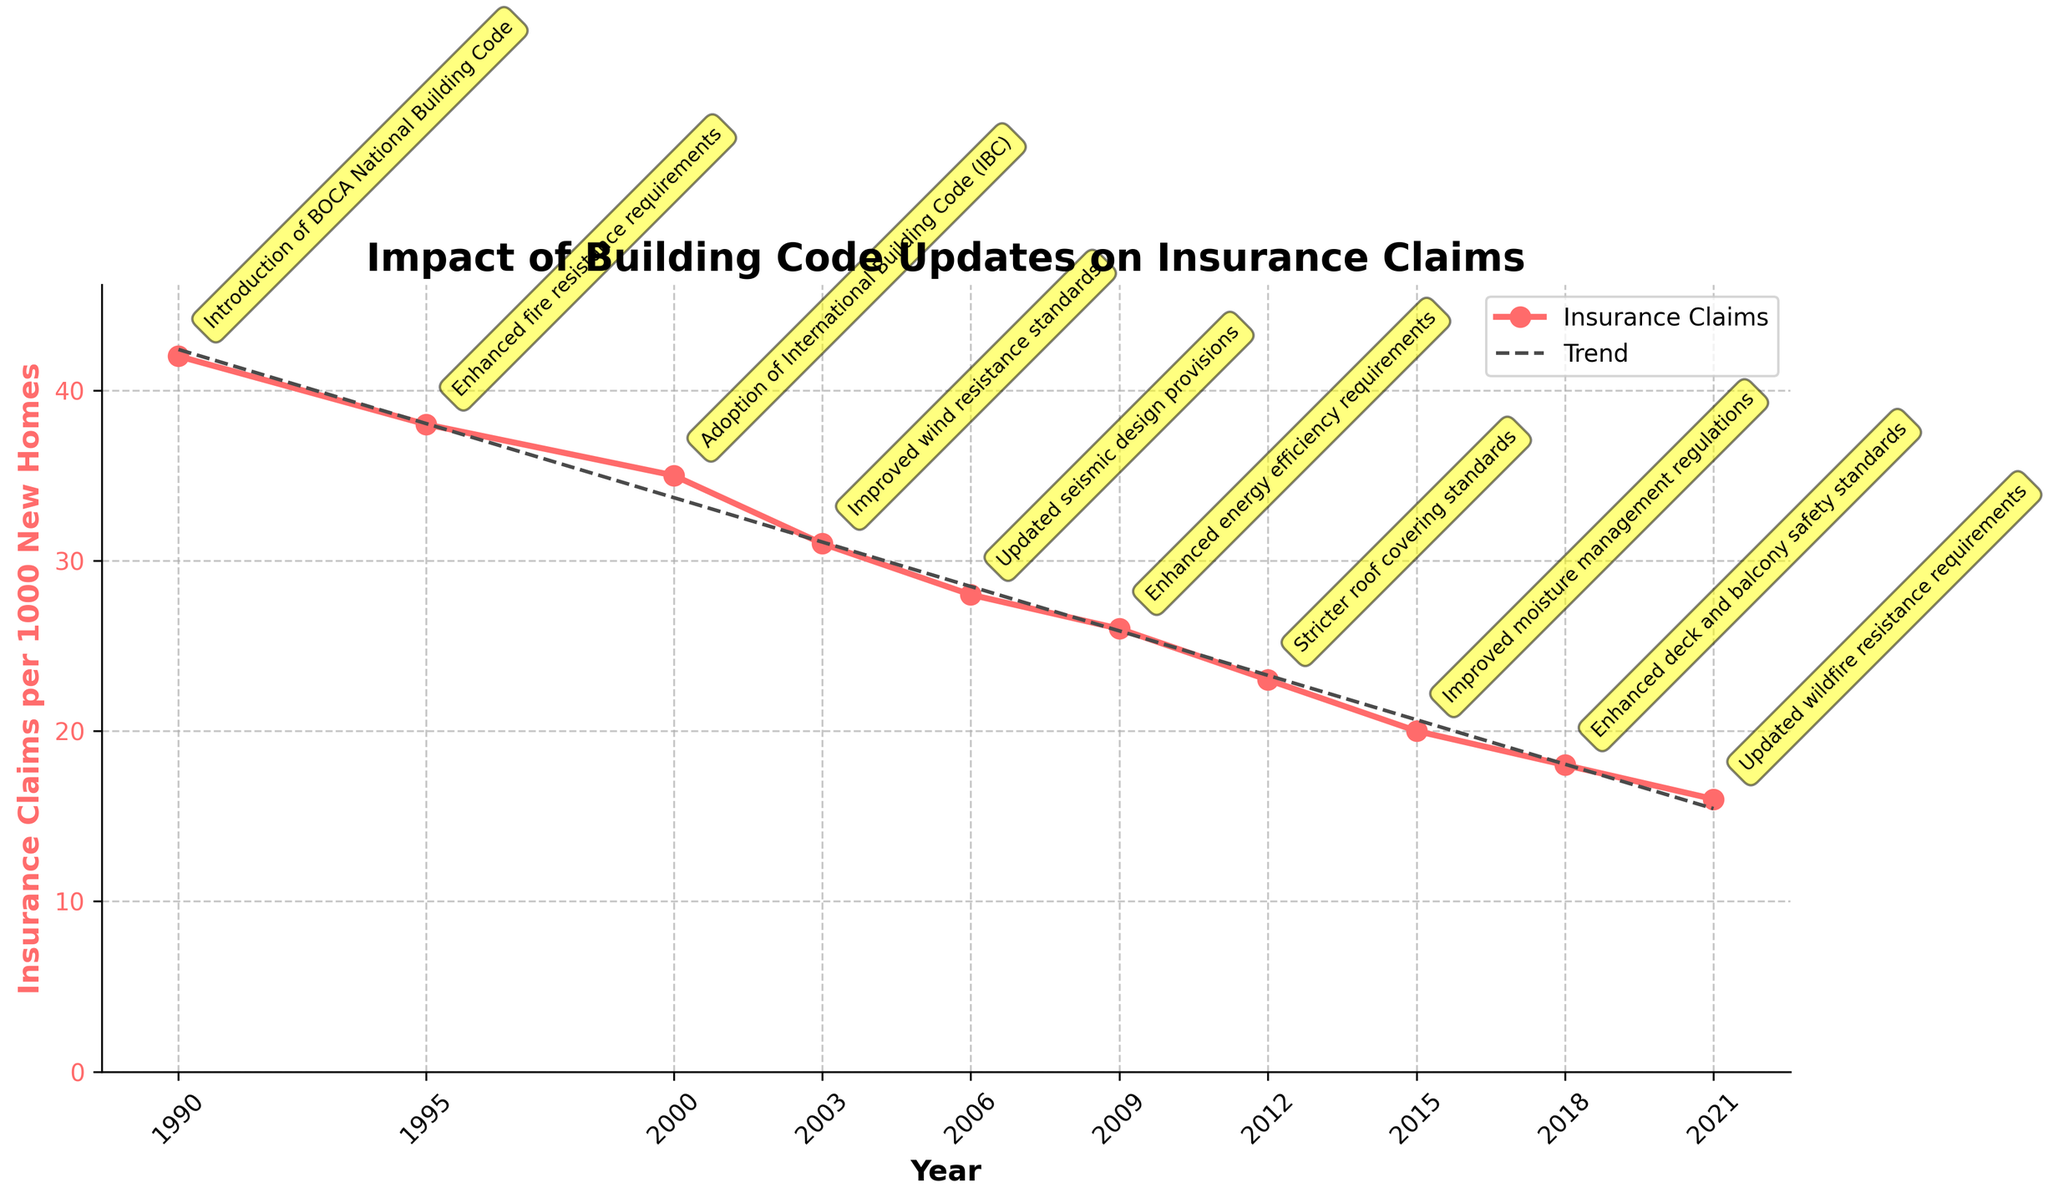What general trend is observed in insurance claims per 1000 new homes over the years? The figure shows a consistent downward trend in the "Insurance Claims per 1000 New Homes" line. Starting from 42 claims in 1990, it declines to 16 claims by 2021. This suggests that insurance claims have decreased over the years, presumably due to improved building code standards.
Answer: Decreasing How did the insurance claims change after the adoption of the International Building Code (IBC) in 2000? In 2000, the insurance claims were 35 per 1000 new homes, and by the next update in 2003, the claims decreased to 31 per 1000 new homes. Thus, there was a 4-claim reduction after adopting the IBC.
Answer: Decreased by 4 Which building code update appears to have reduced the insurance claims the most? The largest single reduction in insurance claims per 1000 new homes occurred between 1990 and 1995, where the introduction of enhanced fire resistance requirements reduced claims from 42 to 38, a difference of 4 claims.
Answer: Enhanced fire resistance requirements What is the difference in insurance claims between the highest and lowest points in the graph? The highest point is 42 claims in 1990, and the lowest point is 16 claims in 2021. The difference between these two points is 42 - 16, which equals 26 claims.
Answer: 26 Which year saw the introduction of stricter roof covering standards, and what was the number of insurance claims in that year? The year 2012 saw the introduction of stricter roof covering standards. The number of insurance claims that year was 23 per 1000 new homes.
Answer: 2012, 23 claims How does the rate of decrease in insurance claims compare between the periods 2003-2006 and 2012-2015? From 2003 to 2006, the claims decreased from 31 to 28, a drop of 3 claims. From 2012 to 2015, the claims decreased from 23 to 20, a drop of 3 claims as well. The rate of decrease in insurance claims is the same, with a difference of 3 claims in both periods.
Answer: Same rate, 3 claims each What visual cue is used to annotate the building code updates, and why might this be helpful? Yellow rounded boxes are used to annotate the building code updates on the graph. This visual cue helps in easily distinguishing the points at which significant changes in building codes occurred and aids in correlating these updates with changes in insurance claims.
Answer: Yellow rounded boxes In which period did the insurance claims decrease the slowest, according to the graph? The insurance claims decreased the slowest between 1995 and 2000, from 38 to 35, showing a reduction of just 3 claims over 5 years.
Answer: 1995-2000 What is the overall percentage decrease in insurance claims from 1990 to 2021? The claims decreased from 42 in 1990 to 16 in 2021. The percentage decrease is calculated by ( (42 - 16) / 42 ) * 100. This equals ((26) / 42) * 100 ≈ 61.90%.
Answer: About 61.90% 